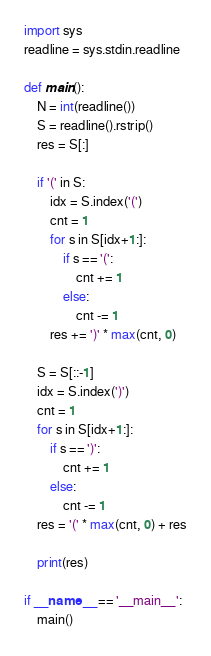Convert code to text. <code><loc_0><loc_0><loc_500><loc_500><_Python_>import sys
readline = sys.stdin.readline

def main():
    N = int(readline())
    S = readline().rstrip()
    res = S[:]

    if '(' in S:
        idx = S.index('(')
        cnt = 1
        for s in S[idx+1:]:
            if s == '(':
                cnt += 1
            else:
                cnt -= 1
        res += ')' * max(cnt, 0)
    
    S = S[::-1]
    idx = S.index(')')
    cnt = 1
    for s in S[idx+1:]:
        if s == ')':
            cnt += 1
        else:
            cnt -= 1
    res = '(' * max(cnt, 0) + res

    print(res)

if __name__ == '__main__':
    main()</code> 